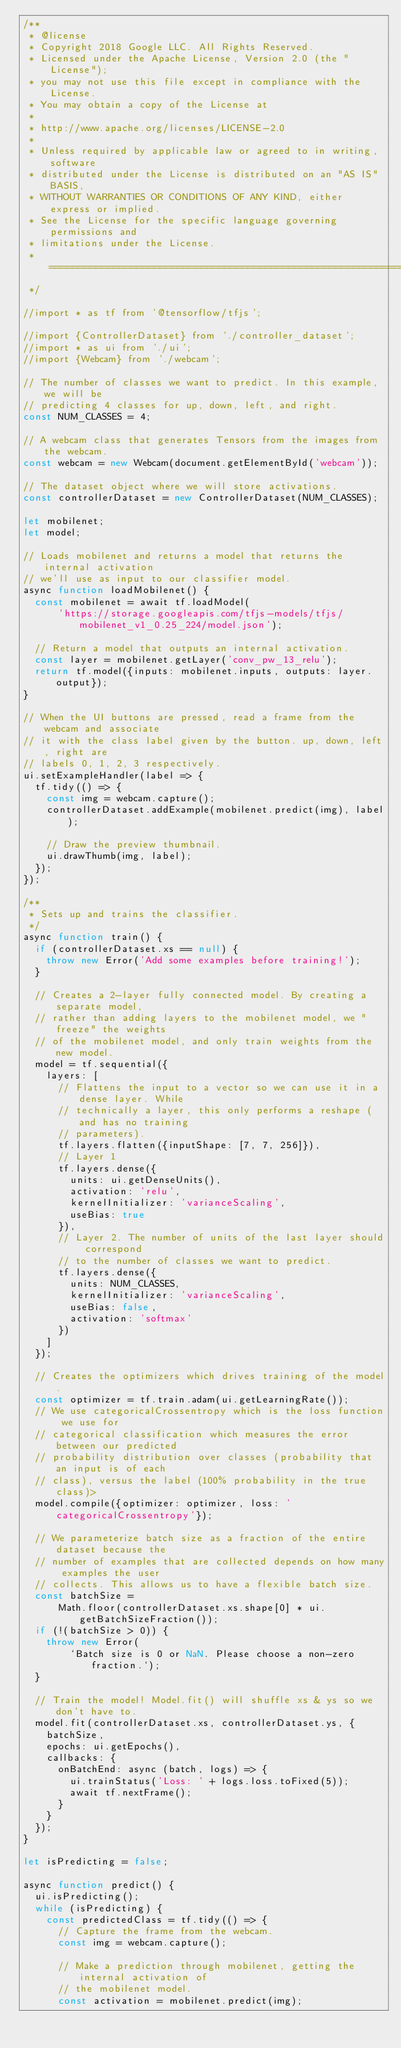Convert code to text. <code><loc_0><loc_0><loc_500><loc_500><_JavaScript_>/**
 * @license
 * Copyright 2018 Google LLC. All Rights Reserved.
 * Licensed under the Apache License, Version 2.0 (the "License");
 * you may not use this file except in compliance with the License.
 * You may obtain a copy of the License at
 *
 * http://www.apache.org/licenses/LICENSE-2.0
 *
 * Unless required by applicable law or agreed to in writing, software
 * distributed under the License is distributed on an "AS IS" BASIS,
 * WITHOUT WARRANTIES OR CONDITIONS OF ANY KIND, either express or implied.
 * See the License for the specific language governing permissions and
 * limitations under the License.
 * =============================================================================
 */

//import * as tf from '@tensorflow/tfjs';

//import {ControllerDataset} from './controller_dataset';
//import * as ui from './ui';
//import {Webcam} from './webcam';

// The number of classes we want to predict. In this example, we will be
// predicting 4 classes for up, down, left, and right.
const NUM_CLASSES = 4;

// A webcam class that generates Tensors from the images from the webcam.
const webcam = new Webcam(document.getElementById('webcam'));

// The dataset object where we will store activations.
const controllerDataset = new ControllerDataset(NUM_CLASSES);

let mobilenet;
let model;

// Loads mobilenet and returns a model that returns the internal activation
// we'll use as input to our classifier model.
async function loadMobilenet() {
  const mobilenet = await tf.loadModel(
      'https://storage.googleapis.com/tfjs-models/tfjs/mobilenet_v1_0.25_224/model.json');

  // Return a model that outputs an internal activation.
  const layer = mobilenet.getLayer('conv_pw_13_relu');
  return tf.model({inputs: mobilenet.inputs, outputs: layer.output});
}

// When the UI buttons are pressed, read a frame from the webcam and associate
// it with the class label given by the button. up, down, left, right are
// labels 0, 1, 2, 3 respectively.
ui.setExampleHandler(label => {
  tf.tidy(() => {
    const img = webcam.capture();
    controllerDataset.addExample(mobilenet.predict(img), label);

    // Draw the preview thumbnail.
    ui.drawThumb(img, label);
  });
});

/**
 * Sets up and trains the classifier.
 */
async function train() {
  if (controllerDataset.xs == null) {
    throw new Error('Add some examples before training!');
  }

  // Creates a 2-layer fully connected model. By creating a separate model,
  // rather than adding layers to the mobilenet model, we "freeze" the weights
  // of the mobilenet model, and only train weights from the new model.
  model = tf.sequential({
    layers: [
      // Flattens the input to a vector so we can use it in a dense layer. While
      // technically a layer, this only performs a reshape (and has no training
      // parameters).
      tf.layers.flatten({inputShape: [7, 7, 256]}),
      // Layer 1
      tf.layers.dense({
        units: ui.getDenseUnits(),
        activation: 'relu',
        kernelInitializer: 'varianceScaling',
        useBias: true
      }),
      // Layer 2. The number of units of the last layer should correspond
      // to the number of classes we want to predict.
      tf.layers.dense({
        units: NUM_CLASSES,
        kernelInitializer: 'varianceScaling',
        useBias: false,
        activation: 'softmax'
      })
    ]
  });

  // Creates the optimizers which drives training of the model.
  const optimizer = tf.train.adam(ui.getLearningRate());
  // We use categoricalCrossentropy which is the loss function we use for
  // categorical classification which measures the error between our predicted
  // probability distribution over classes (probability that an input is of each
  // class), versus the label (100% probability in the true class)>
  model.compile({optimizer: optimizer, loss: 'categoricalCrossentropy'});

  // We parameterize batch size as a fraction of the entire dataset because the
  // number of examples that are collected depends on how many examples the user
  // collects. This allows us to have a flexible batch size.
  const batchSize =
      Math.floor(controllerDataset.xs.shape[0] * ui.getBatchSizeFraction());
  if (!(batchSize > 0)) {
    throw new Error(
        `Batch size is 0 or NaN. Please choose a non-zero fraction.`);
  }

  // Train the model! Model.fit() will shuffle xs & ys so we don't have to.
  model.fit(controllerDataset.xs, controllerDataset.ys, {
    batchSize,
    epochs: ui.getEpochs(),
    callbacks: {
      onBatchEnd: async (batch, logs) => {
        ui.trainStatus('Loss: ' + logs.loss.toFixed(5));
        await tf.nextFrame();
      }
    }
  });
}

let isPredicting = false;

async function predict() {
  ui.isPredicting();
  while (isPredicting) {
    const predictedClass = tf.tidy(() => {
      // Capture the frame from the webcam.
      const img = webcam.capture();

      // Make a prediction through mobilenet, getting the internal activation of
      // the mobilenet model.
      const activation = mobilenet.predict(img);
</code> 